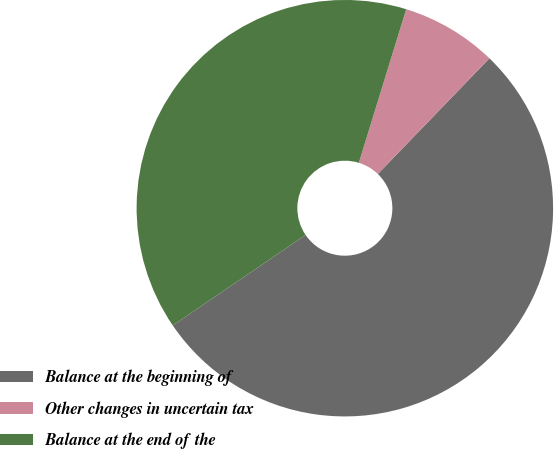Convert chart to OTSL. <chart><loc_0><loc_0><loc_500><loc_500><pie_chart><fcel>Balance at the beginning of<fcel>Other changes in uncertain tax<fcel>Balance at the end of the<nl><fcel>53.27%<fcel>7.45%<fcel>39.28%<nl></chart> 